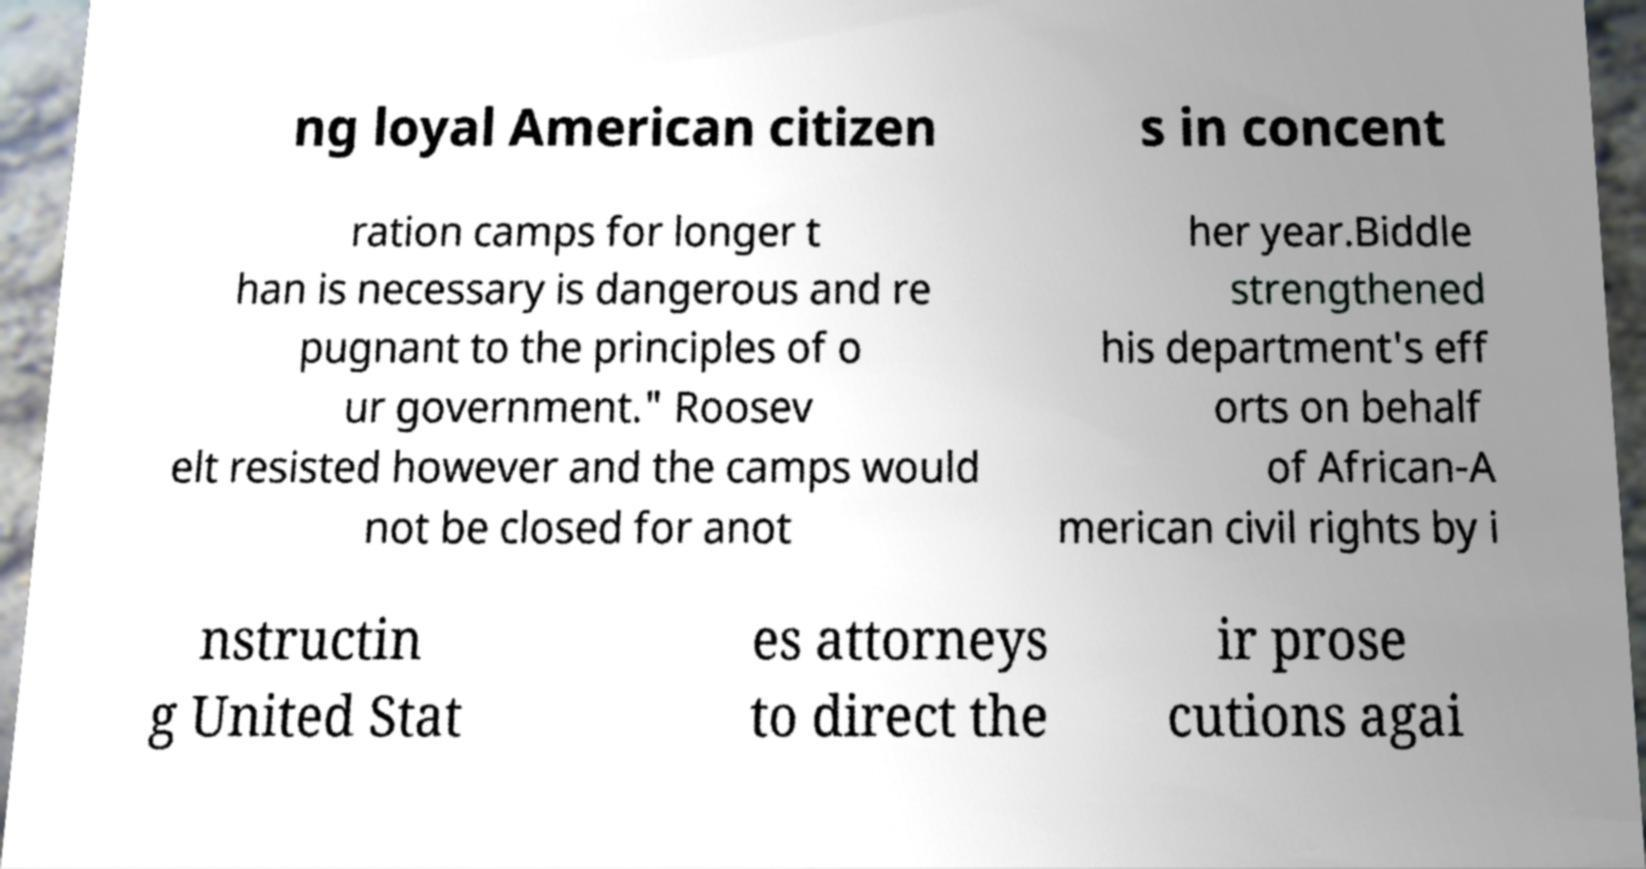I need the written content from this picture converted into text. Can you do that? ng loyal American citizen s in concent ration camps for longer t han is necessary is dangerous and re pugnant to the principles of o ur government." Roosev elt resisted however and the camps would not be closed for anot her year.Biddle strengthened his department's eff orts on behalf of African-A merican civil rights by i nstructin g United Stat es attorneys to direct the ir prose cutions agai 